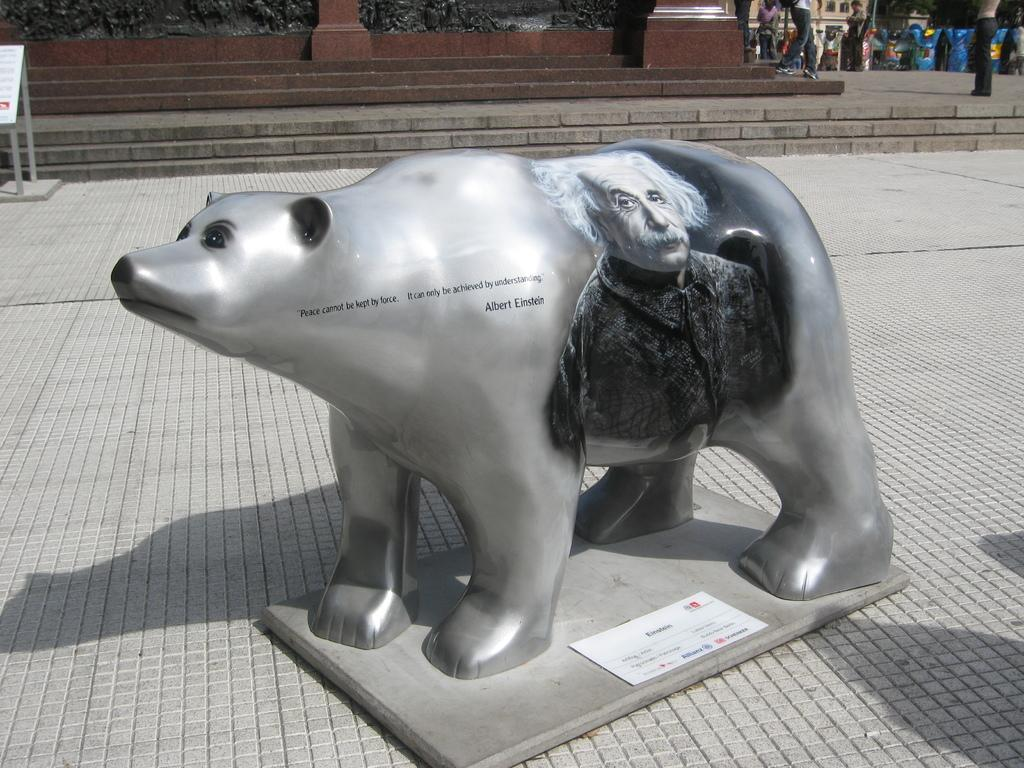What is the main subject of the image? There is a sculpture in the image. What can be seen in the background of the image? There are people and buildings in the background of the image. Where is the board located in the image? The board is on the left side of the image. What type of behavior can be observed in the field in the image? There is no field present in the image, and therefore no behavior can be observed in a field. 